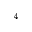Convert formula to latex. <formula><loc_0><loc_0><loc_500><loc_500>^ { 4 }</formula> 